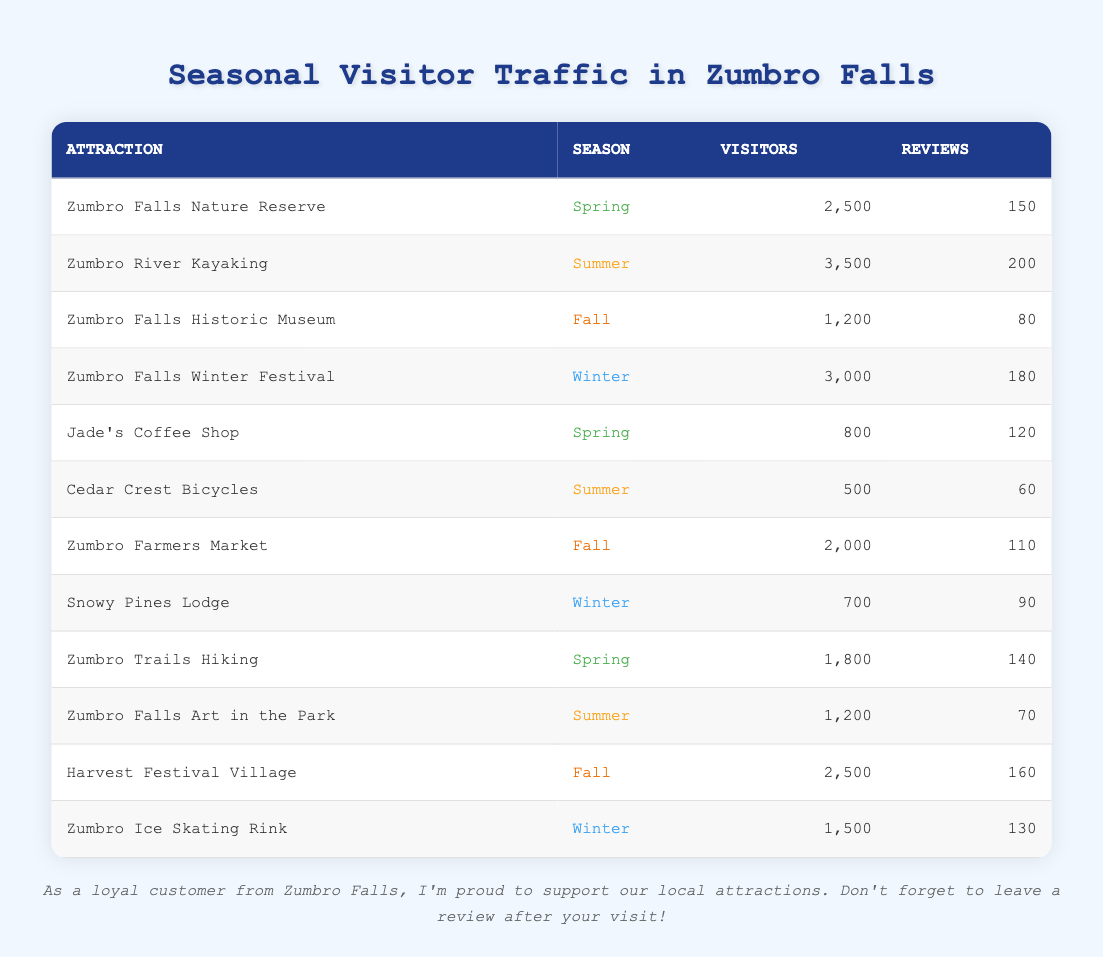What is the total number of visitors to the Zumbro Falls Nature Reserve in Spring? According to the table, the Zumbro Falls Nature Reserve received 2,500 visitors in Spring.
Answer: 2,500 Which attraction had the highest number of visitors during Summer? The table shows that Zumbro River Kayaking had the highest number of visitors with 3,500 during the Summer.
Answer: Zumbro River Kayaking What is the average number of reviews for attractions in Fall? There are three attractions in Fall (Zumbro Falls Historic Museum, Zumbro Farmers Market, and Harvest Festival Village) with 80, 110, and 160 reviews respectively. The total is 80 + 110 + 160 = 350. The average is 350 / 3 = approximately 116.67.
Answer: 116.67 Is there any attraction in Winter that had more visitors than the Zumbro Falls Winter Festival? The table shows the Zumbro Falls Winter Festival had 3,000 visitors in Winter, and the other attractions (Snowy Pines Lodge with 700 and Zumbro Ice Skating Rink with 1,500) had fewer visitors. Therefore, no attraction surpassed this number.
Answer: No What is the difference in visitor numbers between the most popular Summer attraction and the least popular? Zumbro River Kayaking is the most popular with 3,500 visitors, while Cedar Crest Bicycles is the least popular with 500 visitors. The difference is 3,500 - 500 = 3,000.
Answer: 3,000 Which season attracted the least number of visitors to attractions overall? Adding the visitors for each season: Spring (2,500 + 800 + 1,800 = 5,100), Summer (3,500 + 500 + 1,200 = 5,200), Fall (1,200 + 2,000 + 2,500 = 5,700), Winter (3,000 + 700 + 1,500 = 5,200). Winter and Summer have the same total, but Fall has the most visitors, indicating Spring has the least.
Answer: Spring What is the total number of reviews received by Zumbro Falls attractions in Winter? From the table, the Winter attractions are Zumbro Falls Winter Festival (180), Snowy Pines Lodge (90), and Zumbro Ice Skating Rink (130). Summing these gives 180 + 90 + 130 = 400.
Answer: 400 Which Spring attraction has the highest ratio of reviews to visitors? For Zumbro Falls Nature Reserve: 150 reviews / 2,500 visitors = 0.06; Jade's Coffee Shop: 120 / 800 = 0.15; Zumbro Trails Hiking: 140 / 1,800 = 0.0778. Jade's Coffee Shop has the highest ratio.
Answer: Jade's Coffee Shop What is the median number of visitors across all seasons? Listing all visitors: 800, 1,200, 1,500, 1,800, 2,000, 2,500, 2,500, 3,000, 3,500. There are 9 data points, and the median is the 5th value in sorted order, which is 2,000.
Answer: 2,000 How many total reviews were given for attractions during the Spring season? The attractions in Spring are Zumbro Falls Nature Reserve (150 reviews), Jade's Coffee Shop (120 reviews), and Zumbro Trails Hiking (140 reviews). The total reviews are 150 + 120 + 140 = 410.
Answer: 410 